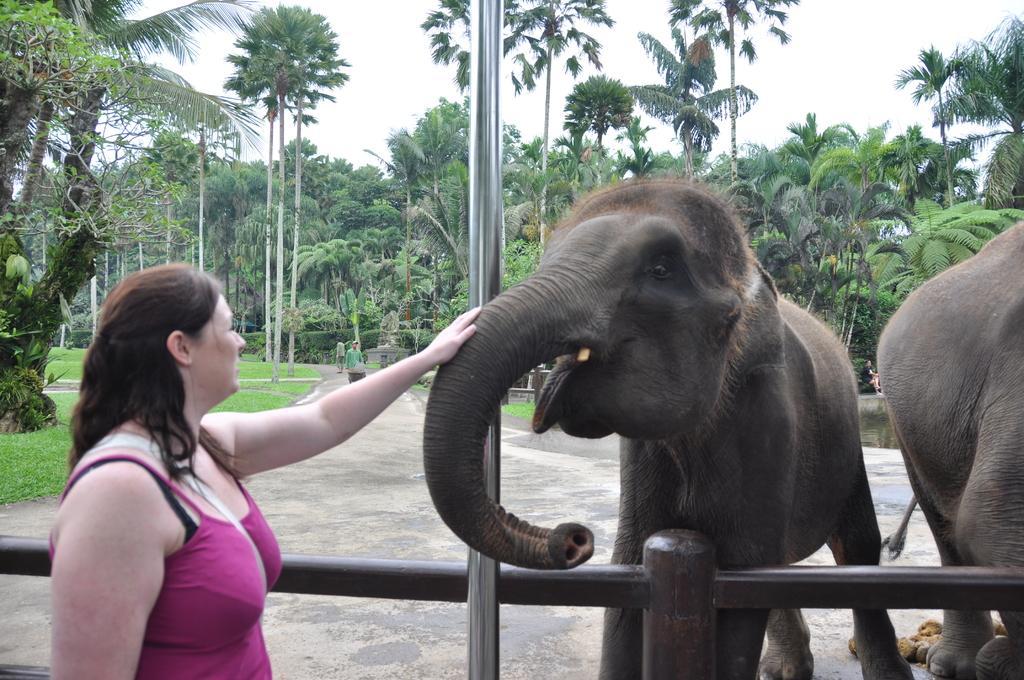In one or two sentences, can you explain what this image depicts? This picture is of outside. On the right there are two elephants standing on the ground. In the center we can see a pole. On the left there is a woman wearing pink color t-shirt and standing, behind her we can see the tree and some grass. In the background we can see the sky and many number of trees and we can see the person's seems to be walking on the ground. 